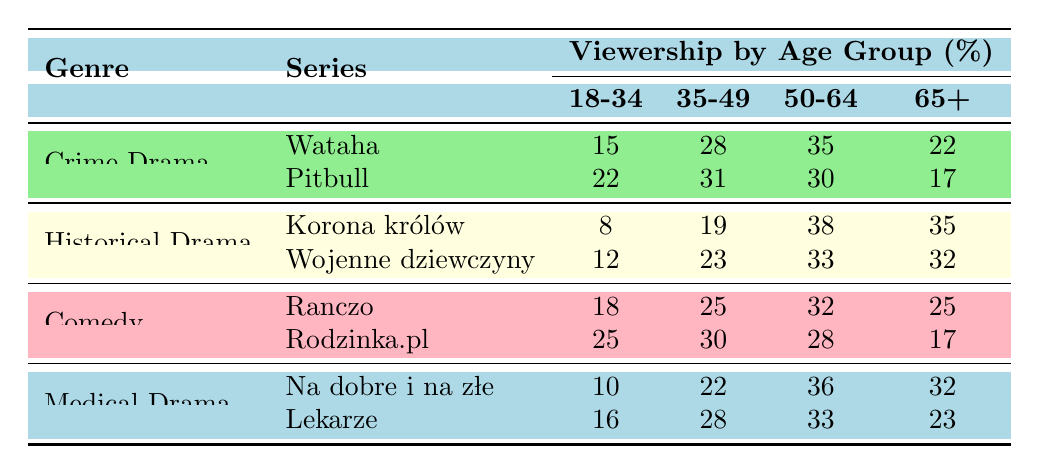What is the viewership percentage for the series "Wataha" among the age group 50-64? From the table, for the series "Wataha," the viewership percentage for the age group 50-64 is directly listed as 35%.
Answer: 35% Which Polish TV series has the highest viewership percentage among the age group 18-34? Looking at the age group 18-34, "Rodzinka.pl" has a viewership percentage of 25%, which is higher than any other series in this age group.
Answer: Rodzinka.pl What is the average viewership percentage for the genre "Comedy" across all age groups? The viewership percentages for "Comedy" series are: Ranczo (18, 25, 32, 25) and Rodzinka.pl (25, 30, 28, 17). Adding them gives: 18 + 25 + 32 + 25 + 25 + 30 + 28 + 17 = 200, and dividing by 8 (the number of age groups) gives an average of 25%.
Answer: 25% Is the viewership percentage for the age group 65+ lower for "Pitbull" than for "Wataha"? "Pitbull" has a viewership percentage of 17% for the age group 65+, while "Wataha" has 22%. Since 17% is less than 22%, the statement is true.
Answer: Yes What is the total viewership percentage for the genre "Historical Drama" in the age group 35-49? The percentages for "Historical Drama" are: Korona królów (19%) and Wojenne dziewczyny (23%). Adding these gives: 19 + 23 = 42%.
Answer: 42% Which age group has the lowest overall viewership percentage for the genre "Medical Drama"? The viewership percentages for the two series in "Medical Drama" are: Na dobre i na złe (10%, 22%, 36%, 32%) and Lekarze (16%, 28%, 33%, 23%). The lowest percentage for any age group is 10% for Na dobre i na złe in the age group 18-34.
Answer: 18-34 How does the viewership for "Korona królów" in the age group 50-64 compare to "Pitbull" in the same age group? For "Korona królów," the viewership percentage for 50-64 is 38%, and for "Pitbull," it is 30%. Since 38% is greater than 30%, "Korona królów" has a higher viewership for that age group.
Answer: Higher Which genre has the most series listed in this table? There are 2 series listed under each genre (Crime Drama, Historical Drama, Comedy, and Medical Drama), meaning all genres have an equal number of series.
Answer: Equal What is the difference in viewership percentage for the age group 65+ between "Na dobre i na złe" and "Lekarze"? For "Na dobre i na złe," the percentage is 32% and for "Lekarze," it is 23%. The difference is calculated as 32 - 23 = 9%.
Answer: 9% 